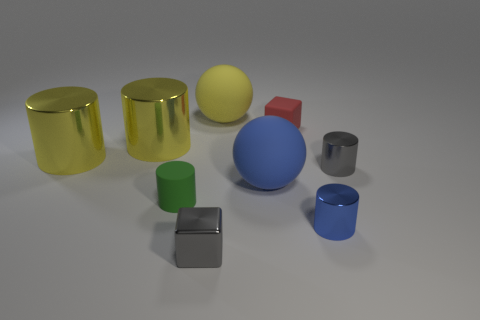There is a red thing that is the same size as the blue metallic cylinder; what shape is it?
Offer a terse response. Cube. What is the material of the gray thing on the left side of the tiny matte object right of the cube in front of the small green rubber object?
Make the answer very short. Metal. Is the shape of the blue object on the right side of the small red rubber block the same as the tiny gray shiny object behind the tiny green rubber cylinder?
Offer a very short reply. Yes. What number of other objects are there of the same material as the green cylinder?
Make the answer very short. 3. Is the blue object that is to the left of the small blue thing made of the same material as the small red thing in front of the yellow matte sphere?
Your response must be concise. Yes. The big blue object that is made of the same material as the red cube is what shape?
Give a very brief answer. Sphere. Are there any other things that are the same color as the rubber cylinder?
Provide a short and direct response. No. How many small shiny blocks are there?
Give a very brief answer. 1. What is the shape of the tiny thing that is to the right of the large blue ball and in front of the green matte object?
Your answer should be very brief. Cylinder. The small gray thing that is to the right of the tiny shiny thing in front of the cylinder in front of the green rubber cylinder is what shape?
Your answer should be compact. Cylinder. 